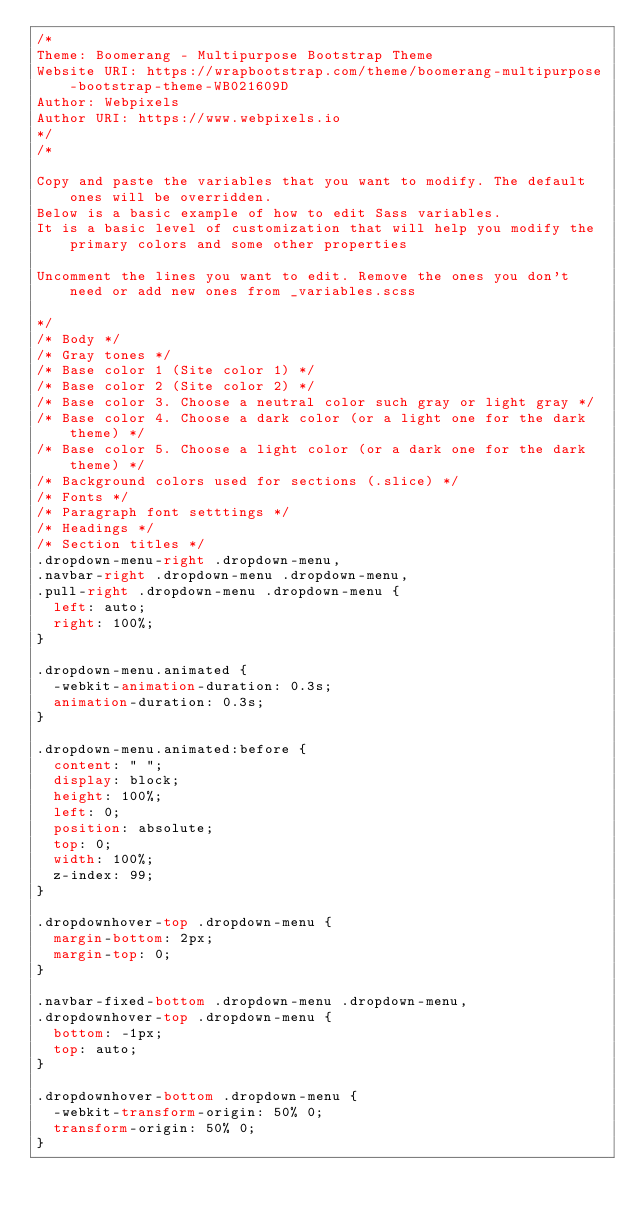<code> <loc_0><loc_0><loc_500><loc_500><_CSS_>/*
Theme: Boomerang - Multipurpose Bootstrap Theme
Website URI: https://wrapbootstrap.com/theme/boomerang-multipurpose-bootstrap-theme-WB021609D
Author: Webpixels
Author URI: https://www.webpixels.io
*/
/* 

Copy and paste the variables that you want to modify. The default ones will be overridden.
Below is a basic example of how to edit Sass variables. 
It is a basic level of customization that will help you modify the primary colors and some other properties

Uncomment the lines you want to edit. Remove the ones you don't need or add new ones from _variables.scss

*/
/* Body */
/* Gray tones */
/* Base color 1 (Site color 1) */
/* Base color 2 (Site color 2) */
/* Base color 3. Choose a neutral color such gray or light gray */
/* Base color 4. Choose a dark color (or a light one for the dark theme) */
/* Base color 5. Choose a light color (or a dark one for the dark theme) */
/* Background colors used for sections (.slice) */
/* Fonts */
/* Paragraph font setttings */
/* Headings */
/* Section titles */
.dropdown-menu-right .dropdown-menu,
.navbar-right .dropdown-menu .dropdown-menu,
.pull-right .dropdown-menu .dropdown-menu {
  left: auto;
  right: 100%;
}

.dropdown-menu.animated {
  -webkit-animation-duration: 0.3s;
  animation-duration: 0.3s;
}

.dropdown-menu.animated:before {
  content: " ";
  display: block;
  height: 100%;
  left: 0;
  position: absolute;
  top: 0;
  width: 100%;
  z-index: 99;
}

.dropdownhover-top .dropdown-menu {
  margin-bottom: 2px;
  margin-top: 0;
}

.navbar-fixed-bottom .dropdown-menu .dropdown-menu,
.dropdownhover-top .dropdown-menu {
  bottom: -1px;
  top: auto;
}

.dropdownhover-bottom .dropdown-menu {
  -webkit-transform-origin: 50% 0;
  transform-origin: 50% 0;
}
</code> 